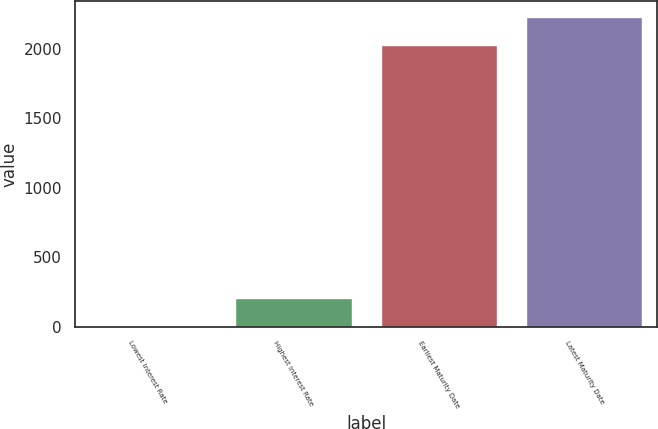<chart> <loc_0><loc_0><loc_500><loc_500><bar_chart><fcel>Lowest Interest Rate<fcel>Highest Interest Rate<fcel>Earliest Maturity Date<fcel>Latest Maturity Date<nl><fcel>2.15<fcel>204.84<fcel>2028<fcel>2230.68<nl></chart> 